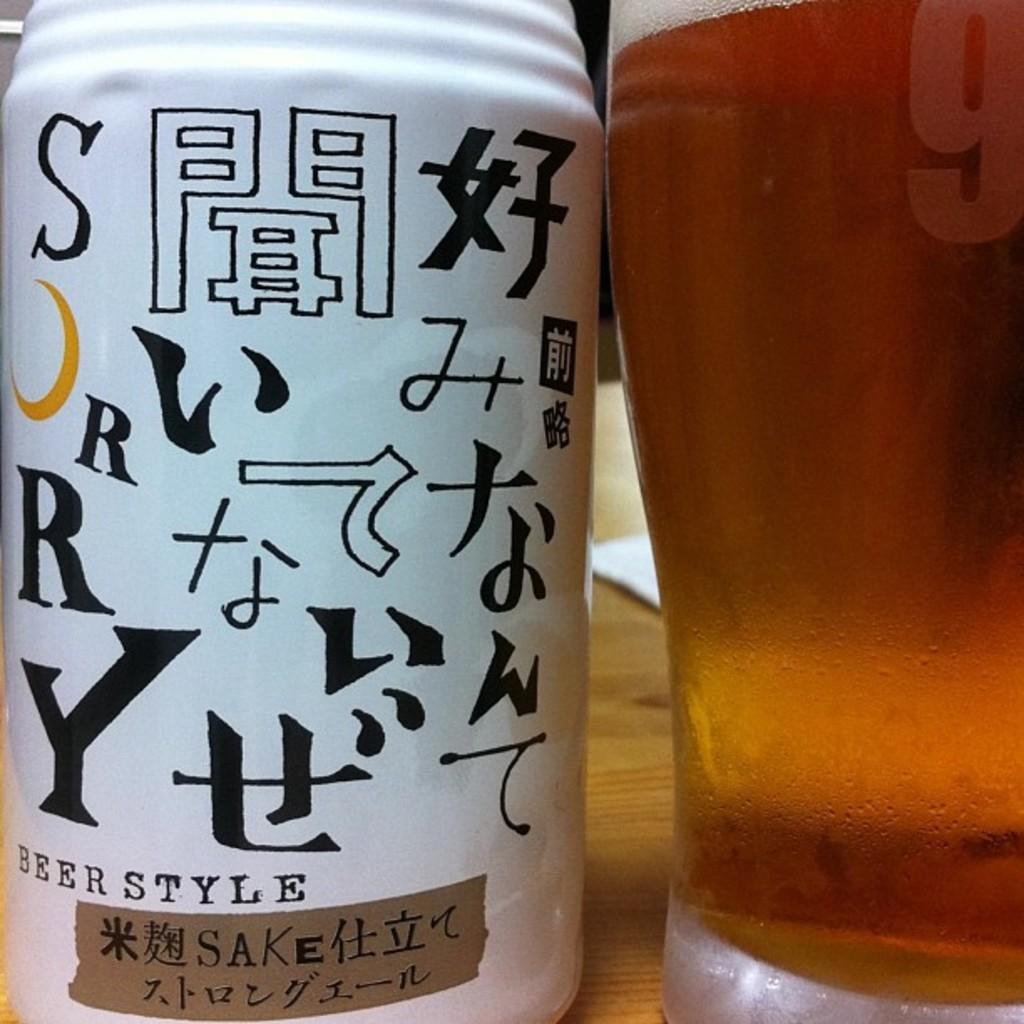<image>
Provide a brief description of the given image. A can and glass of beer style sake 